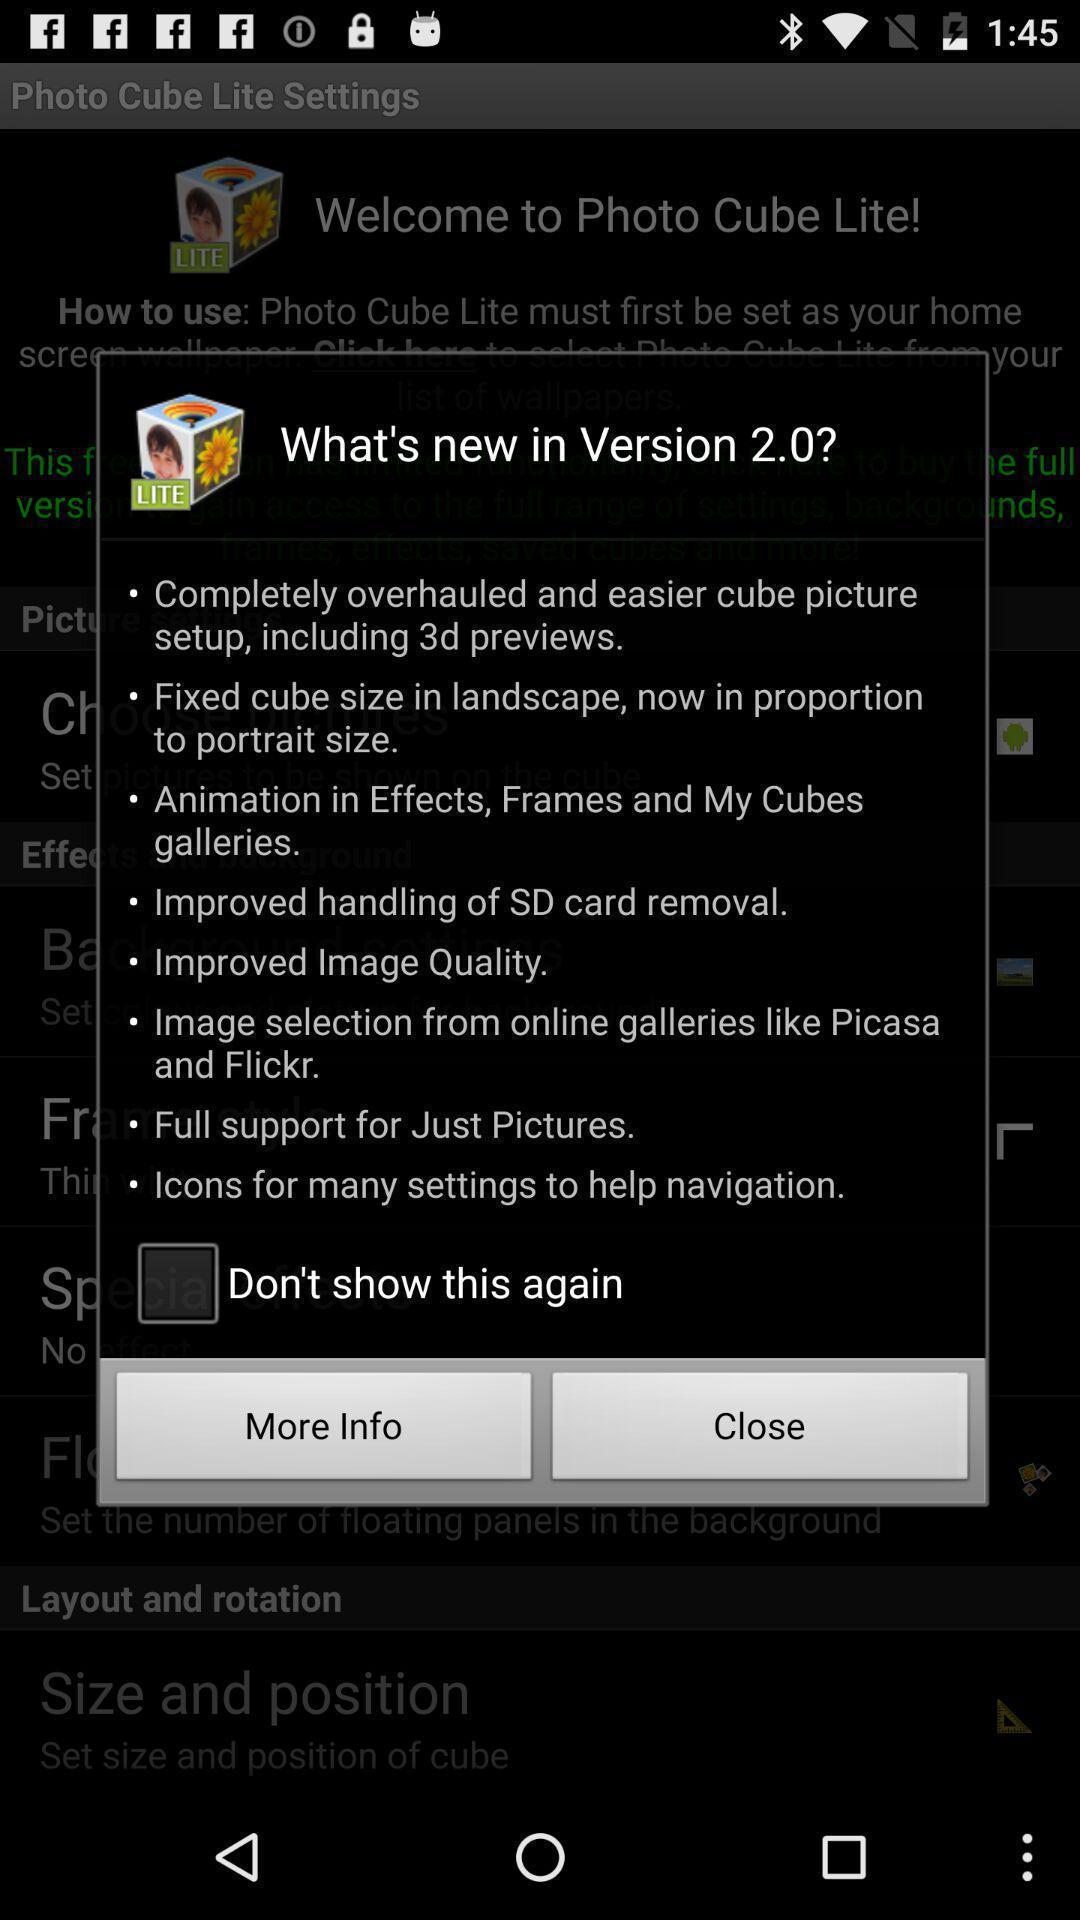What details can you identify in this image? Pop-up displaying about new version in app. 